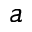Convert formula to latex. <formula><loc_0><loc_0><loc_500><loc_500>a</formula> 